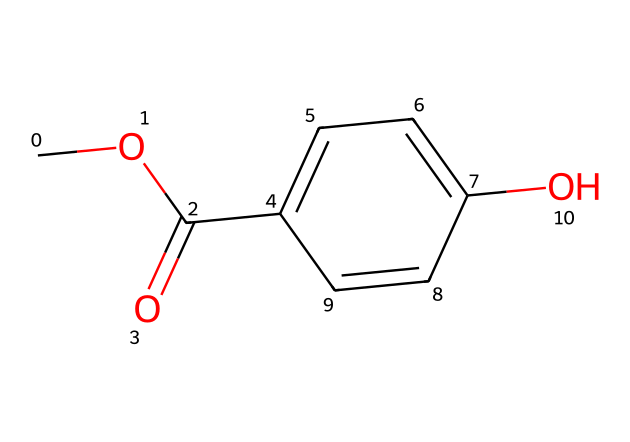What is the molecular formula of methylparaben? To find the molecular formula, we identify the types and numbers of atoms present in the chemical structure represented by the SMILES notation. The structure contains 8 carbon atoms (C), 8 hydrogen atoms (H), and 3 oxygen atoms (O), leading us to the formula C8H8O3.
Answer: C8H8O3 How many rings are present in the structure of methylparaben? Observing the structure from the SMILES, we see there is a phenolic ring represented by "C1=CC=C(C=C1)", which indicates that there is one cyclic structure present.
Answer: 1 What is the functional group in methylparaben? By analyzing the structure, we see the presence of the ester group from the "COC(=O)", which indicates that this molecule is a derivative of a carboxylic acid with an alcohol. It also has a hydroxyl group indicated by "O" attached to the benzene ring, further confirming its classification as a phenolic ester.
Answer: ester Does methylparaben contain any aromatic rings? In the SMILES representation, the part "C1=CC=C(C=C1)" signifies that there is a benzene ring, which is an aromatic structure, due to alternating double bonds present in its cyclic configuration.
Answer: yes What role does methylparaben serve in personal care products? Methylparaben is a widely used preservative, and its role is to inhibit the growth of bacteria, fungi, and other microorganisms in personal care products, helping to prolong the shelf life of these items.
Answer: preservative How many oxygen atoms are present in the structure? Inspecting the SMILES notation "COC(=O)", there are two oxygen atoms identified in the "C(=O)" and one in "CO", leading to a total of 3 oxygen atoms.
Answer: 3 